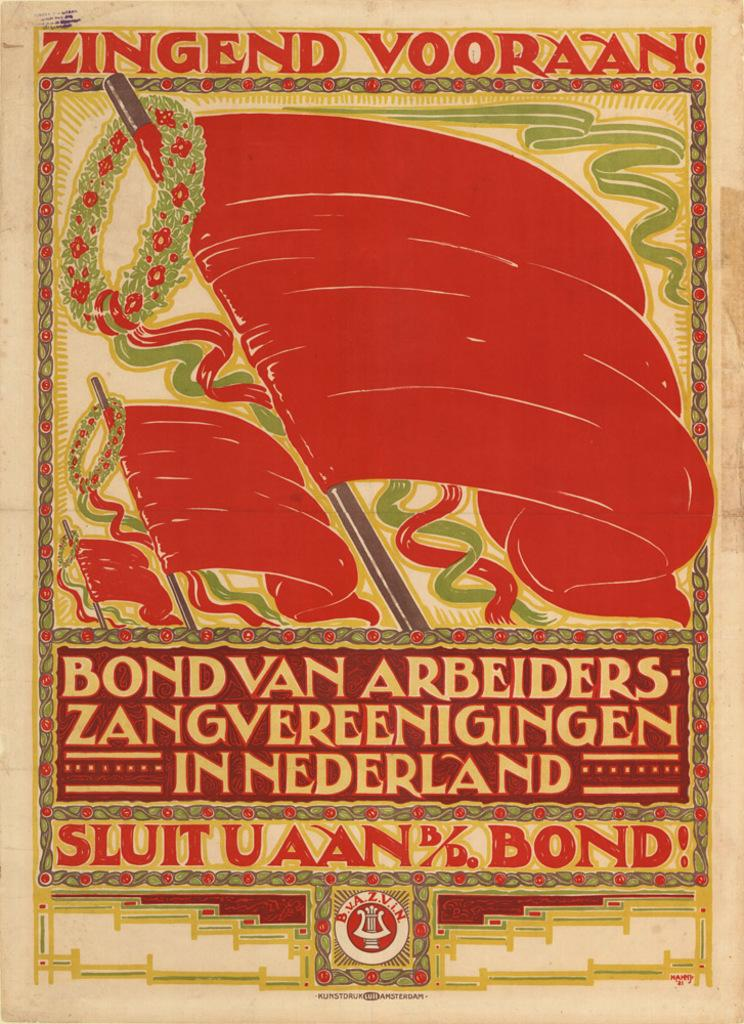<image>
Render a clear and concise summary of the photo. A colorful poster in orange, green and yellow with Sluituaan bond on the bottom. 